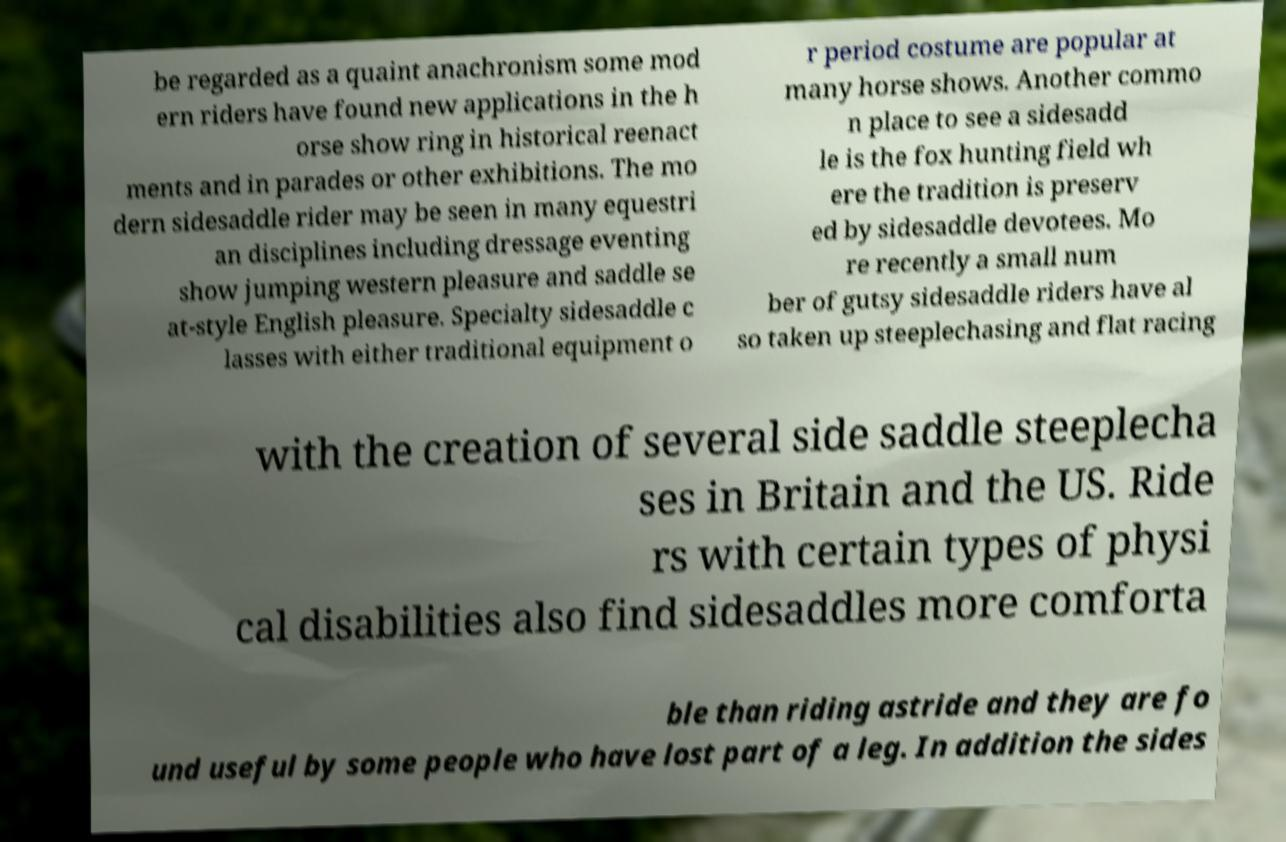For documentation purposes, I need the text within this image transcribed. Could you provide that? be regarded as a quaint anachronism some mod ern riders have found new applications in the h orse show ring in historical reenact ments and in parades or other exhibitions. The mo dern sidesaddle rider may be seen in many equestri an disciplines including dressage eventing show jumping western pleasure and saddle se at-style English pleasure. Specialty sidesaddle c lasses with either traditional equipment o r period costume are popular at many horse shows. Another commo n place to see a sidesadd le is the fox hunting field wh ere the tradition is preserv ed by sidesaddle devotees. Mo re recently a small num ber of gutsy sidesaddle riders have al so taken up steeplechasing and flat racing with the creation of several side saddle steeplecha ses in Britain and the US. Ride rs with certain types of physi cal disabilities also find sidesaddles more comforta ble than riding astride and they are fo und useful by some people who have lost part of a leg. In addition the sides 